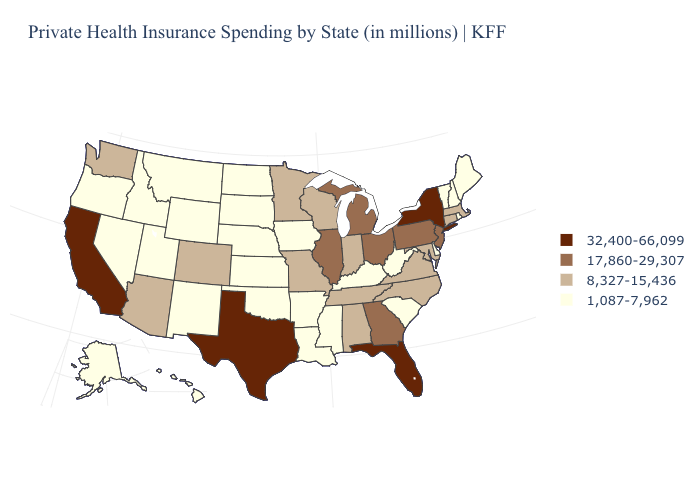Which states have the lowest value in the USA?
Concise answer only. Alaska, Arkansas, Delaware, Hawaii, Idaho, Iowa, Kansas, Kentucky, Louisiana, Maine, Mississippi, Montana, Nebraska, Nevada, New Hampshire, New Mexico, North Dakota, Oklahoma, Oregon, Rhode Island, South Carolina, South Dakota, Utah, Vermont, West Virginia, Wyoming. What is the value of Texas?
Concise answer only. 32,400-66,099. What is the lowest value in the MidWest?
Write a very short answer. 1,087-7,962. Name the states that have a value in the range 32,400-66,099?
Quick response, please. California, Florida, New York, Texas. What is the highest value in the USA?
Keep it brief. 32,400-66,099. What is the value of Montana?
Answer briefly. 1,087-7,962. Name the states that have a value in the range 1,087-7,962?
Keep it brief. Alaska, Arkansas, Delaware, Hawaii, Idaho, Iowa, Kansas, Kentucky, Louisiana, Maine, Mississippi, Montana, Nebraska, Nevada, New Hampshire, New Mexico, North Dakota, Oklahoma, Oregon, Rhode Island, South Carolina, South Dakota, Utah, Vermont, West Virginia, Wyoming. Name the states that have a value in the range 8,327-15,436?
Quick response, please. Alabama, Arizona, Colorado, Connecticut, Indiana, Maryland, Massachusetts, Minnesota, Missouri, North Carolina, Tennessee, Virginia, Washington, Wisconsin. Does the map have missing data?
Short answer required. No. How many symbols are there in the legend?
Be succinct. 4. Among the states that border Nevada , does Oregon have the highest value?
Write a very short answer. No. Does the first symbol in the legend represent the smallest category?
Give a very brief answer. No. Among the states that border Iowa , which have the highest value?
Give a very brief answer. Illinois. Among the states that border Tennessee , which have the highest value?
Answer briefly. Georgia. Name the states that have a value in the range 8,327-15,436?
Answer briefly. Alabama, Arizona, Colorado, Connecticut, Indiana, Maryland, Massachusetts, Minnesota, Missouri, North Carolina, Tennessee, Virginia, Washington, Wisconsin. 